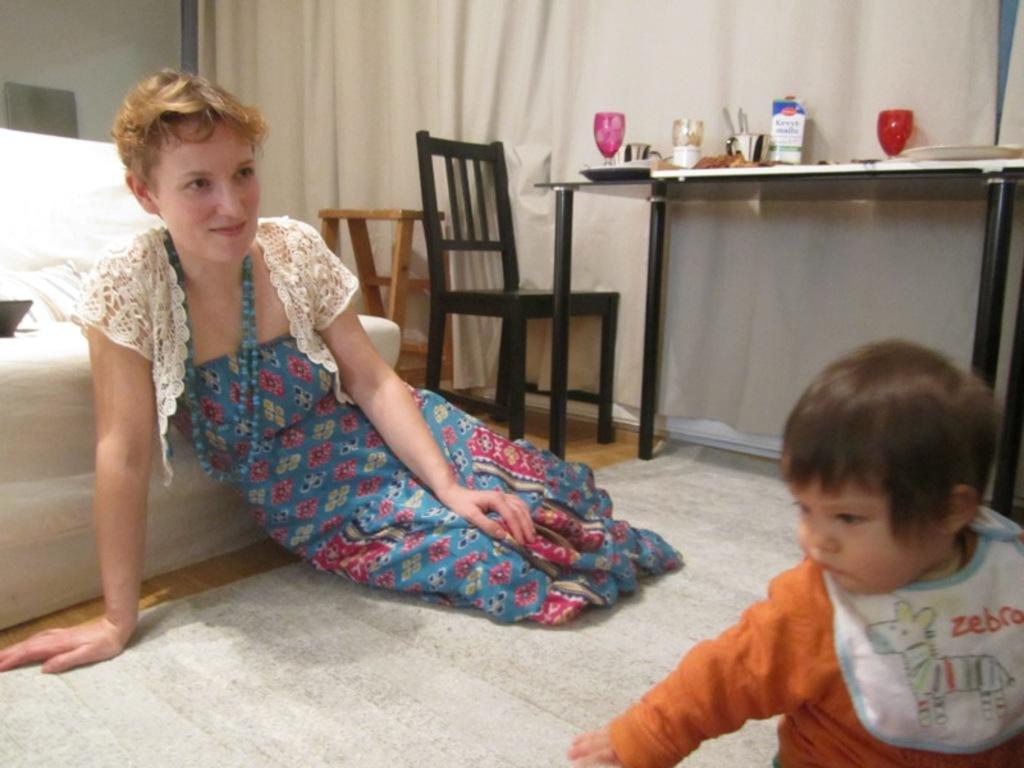<image>
Relay a brief, clear account of the picture shown. a baby that has the word zebra on them 